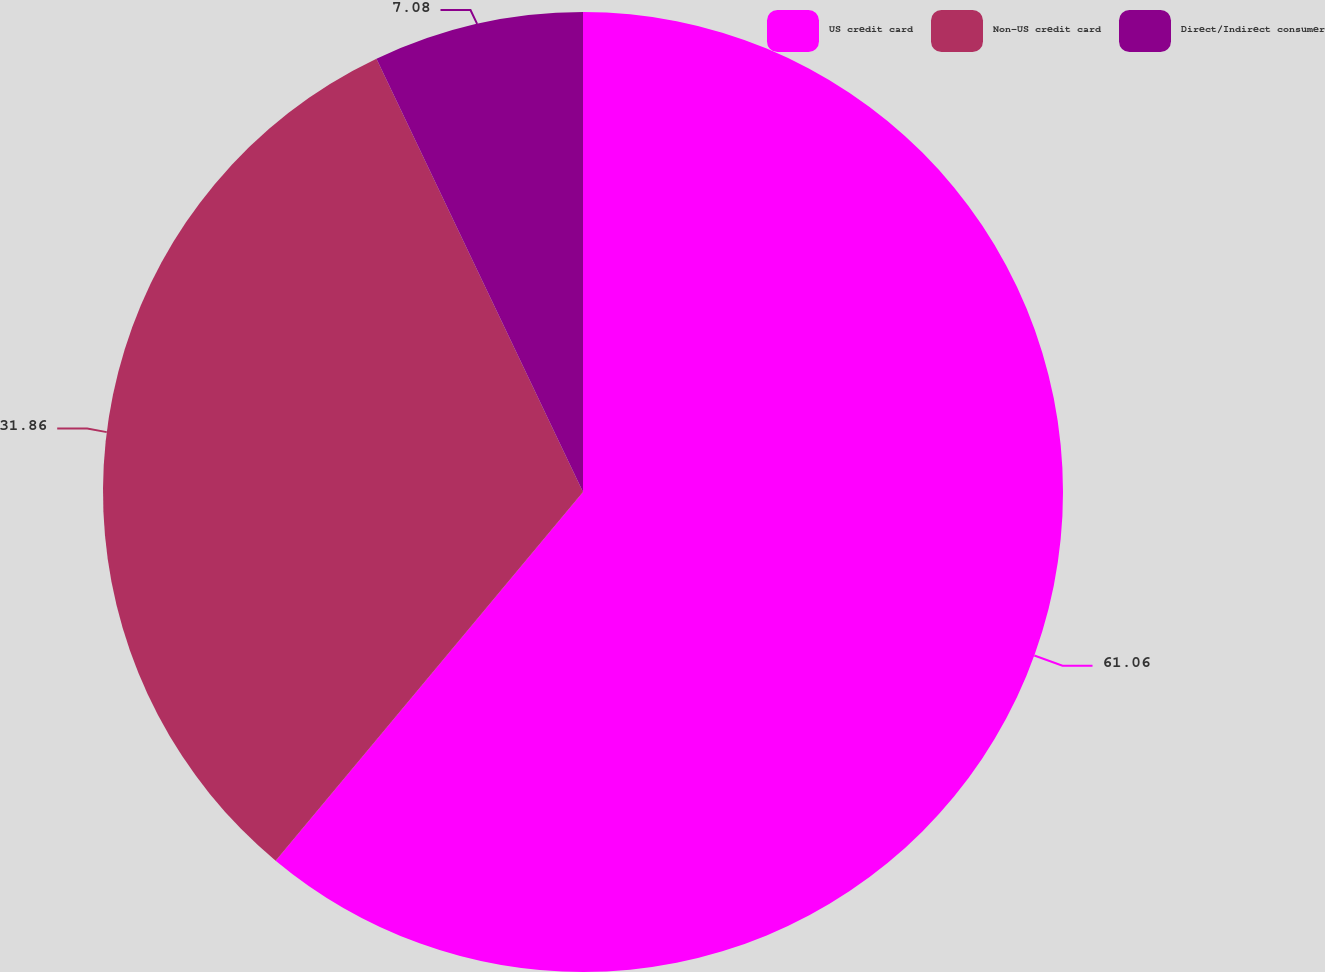Convert chart to OTSL. <chart><loc_0><loc_0><loc_500><loc_500><pie_chart><fcel>US credit card<fcel>Non-US credit card<fcel>Direct/Indirect consumer<nl><fcel>61.06%<fcel>31.86%<fcel>7.08%<nl></chart> 